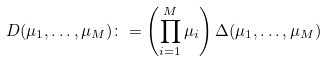Convert formula to latex. <formula><loc_0><loc_0><loc_500><loc_500>D ( \mu _ { 1 } , \dots , \mu _ { M } ) \colon = \left ( \prod _ { i = 1 } ^ { M } \mu _ { i } \right ) \Delta ( \mu _ { 1 } , \dots , \mu _ { M } )</formula> 